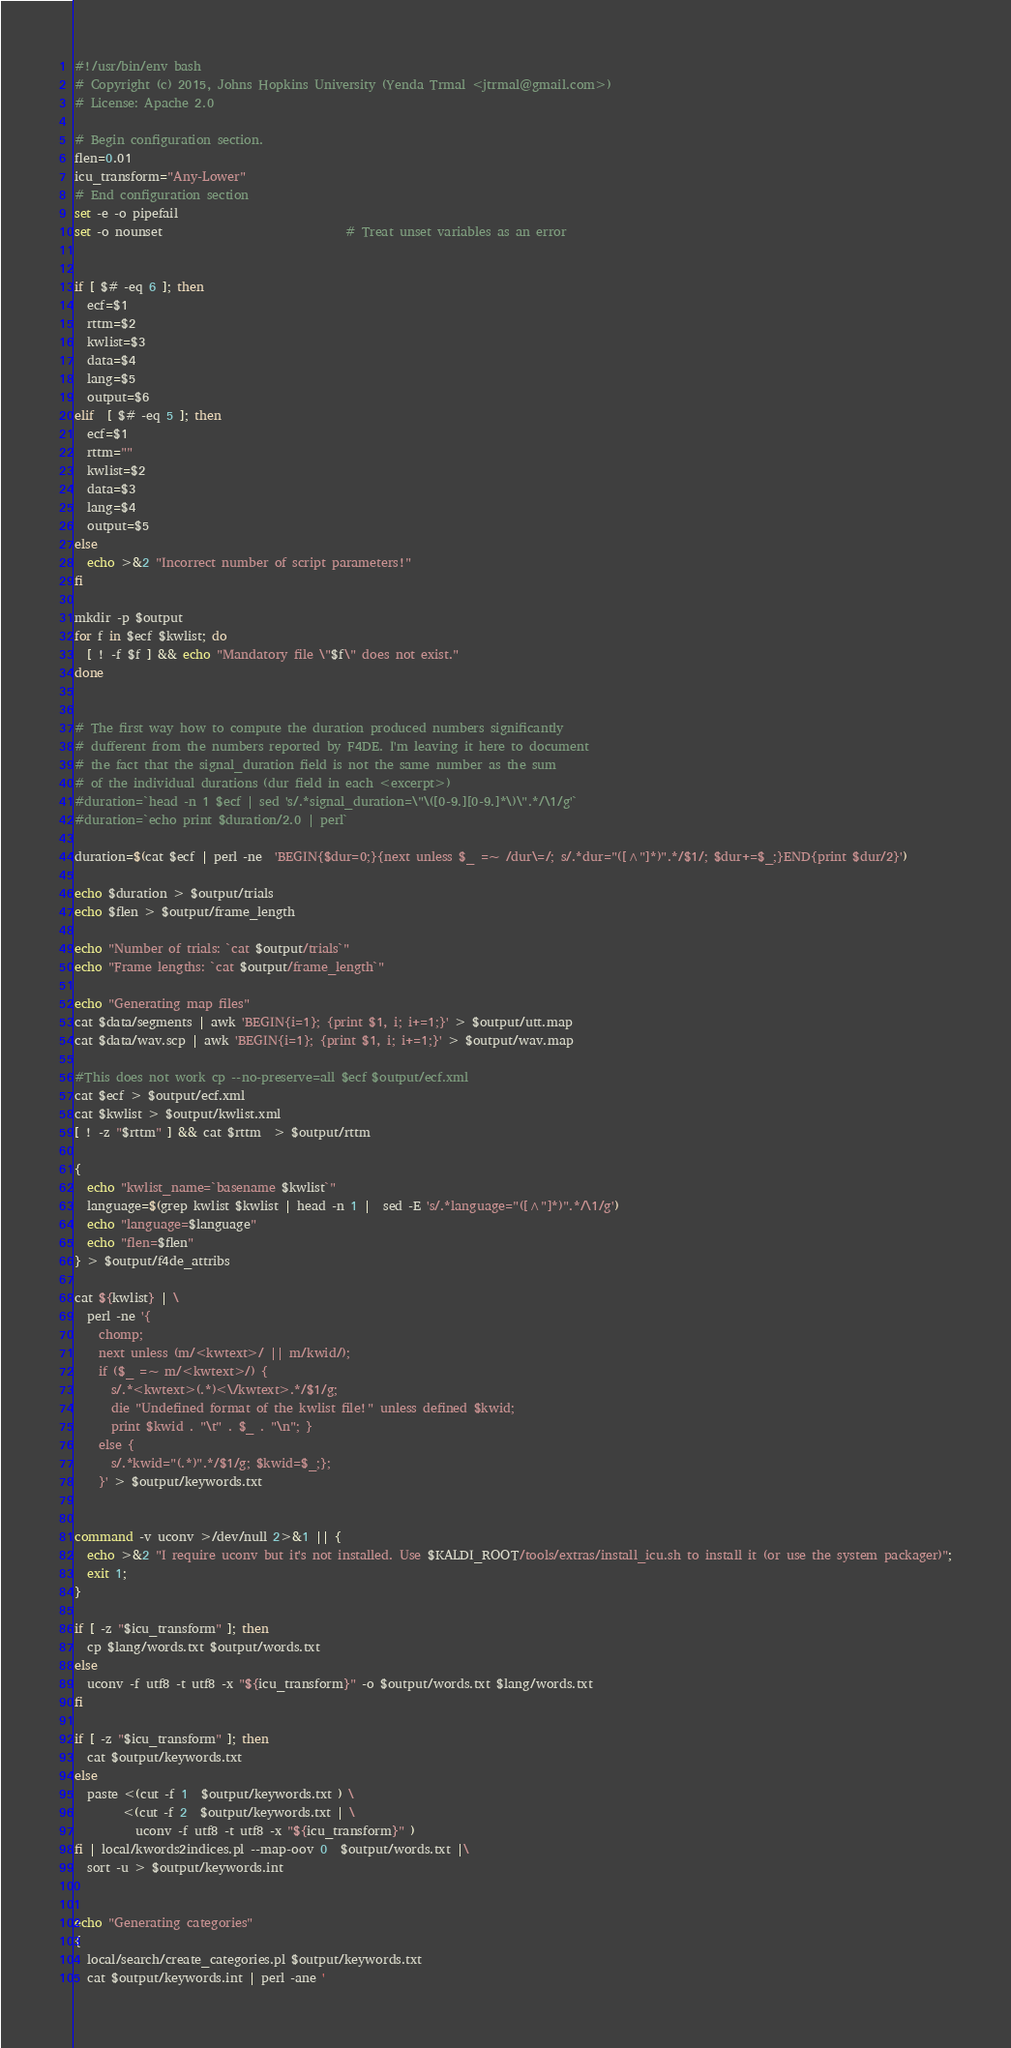Convert code to text. <code><loc_0><loc_0><loc_500><loc_500><_Bash_>#!/usr/bin/env bash
# Copyright (c) 2015, Johns Hopkins University (Yenda Trmal <jtrmal@gmail.com>)
# License: Apache 2.0

# Begin configuration section.
flen=0.01
icu_transform="Any-Lower"
# End configuration section
set -e -o pipefail
set -o nounset                              # Treat unset variables as an error


if [ $# -eq 6 ]; then
  ecf=$1
  rttm=$2
  kwlist=$3
  data=$4
  lang=$5
  output=$6
elif  [ $# -eq 5 ]; then
  ecf=$1
  rttm=""
  kwlist=$2
  data=$3
  lang=$4
  output=$5
else
  echo >&2 "Incorrect number of script parameters!"
fi

mkdir -p $output
for f in $ecf $kwlist; do
  [ ! -f $f ] && echo "Mandatory file \"$f\" does not exist."
done


# The first way how to compute the duration produced numbers significantly
# dufferent from the numbers reported by F4DE. I'm leaving it here to document
# the fact that the signal_duration field is not the same number as the sum
# of the individual durations (dur field in each <excerpt>)
#duration=`head -n 1 $ecf | sed 's/.*signal_duration=\"\([0-9.][0-9.]*\)\".*/\1/g'`
#duration=`echo print $duration/2.0 | perl`

duration=$(cat $ecf | perl -ne  'BEGIN{$dur=0;}{next unless $_ =~ /dur\=/; s/.*dur="([^"]*)".*/$1/; $dur+=$_;}END{print $dur/2}')

echo $duration > $output/trials
echo $flen > $output/frame_length

echo "Number of trials: `cat $output/trials`"
echo "Frame lengths: `cat $output/frame_length`"

echo "Generating map files"
cat $data/segments | awk 'BEGIN{i=1}; {print $1, i; i+=1;}' > $output/utt.map
cat $data/wav.scp | awk 'BEGIN{i=1}; {print $1, i; i+=1;}' > $output/wav.map

#This does not work cp --no-preserve=all $ecf $output/ecf.xml
cat $ecf > $output/ecf.xml
cat $kwlist > $output/kwlist.xml
[ ! -z "$rttm" ] && cat $rttm  > $output/rttm

{
  echo "kwlist_name=`basename $kwlist`"
  language=$(grep kwlist $kwlist | head -n 1 |  sed -E 's/.*language="([^"]*)".*/\1/g')
  echo "language=$language"
  echo "flen=$flen"
} > $output/f4de_attribs

cat ${kwlist} | \
  perl -ne '{
    chomp;
    next unless (m/<kwtext>/ || m/kwid/);
    if ($_ =~ m/<kwtext>/) {
      s/.*<kwtext>(.*)<\/kwtext>.*/$1/g;
      die "Undefined format of the kwlist file!" unless defined $kwid;
      print $kwid . "\t" . $_ . "\n"; }
    else {
      s/.*kwid="(.*)".*/$1/g; $kwid=$_;};
    }' > $output/keywords.txt


command -v uconv >/dev/null 2>&1 || {
  echo >&2 "I require uconv but it's not installed. Use $KALDI_ROOT/tools/extras/install_icu.sh to install it (or use the system packager)";
  exit 1;
}

if [ -z "$icu_transform" ]; then
  cp $lang/words.txt $output/words.txt
else
  uconv -f utf8 -t utf8 -x "${icu_transform}" -o $output/words.txt $lang/words.txt
fi

if [ -z "$icu_transform" ]; then
  cat $output/keywords.txt
else
  paste <(cut -f 1  $output/keywords.txt ) \
        <(cut -f 2  $output/keywords.txt | \
          uconv -f utf8 -t utf8 -x "${icu_transform}" )
fi | local/kwords2indices.pl --map-oov 0  $output/words.txt |\
  sort -u > $output/keywords.int


echo "Generating categories"
{
  local/search/create_categories.pl $output/keywords.txt
  cat $output/keywords.int | perl -ane '</code> 